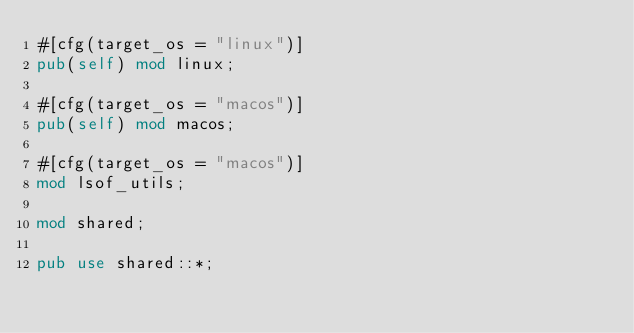<code> <loc_0><loc_0><loc_500><loc_500><_Rust_>#[cfg(target_os = "linux")]
pub(self) mod linux;

#[cfg(target_os = "macos")]
pub(self) mod macos;

#[cfg(target_os = "macos")]
mod lsof_utils;

mod shared;

pub use shared::*;
</code> 